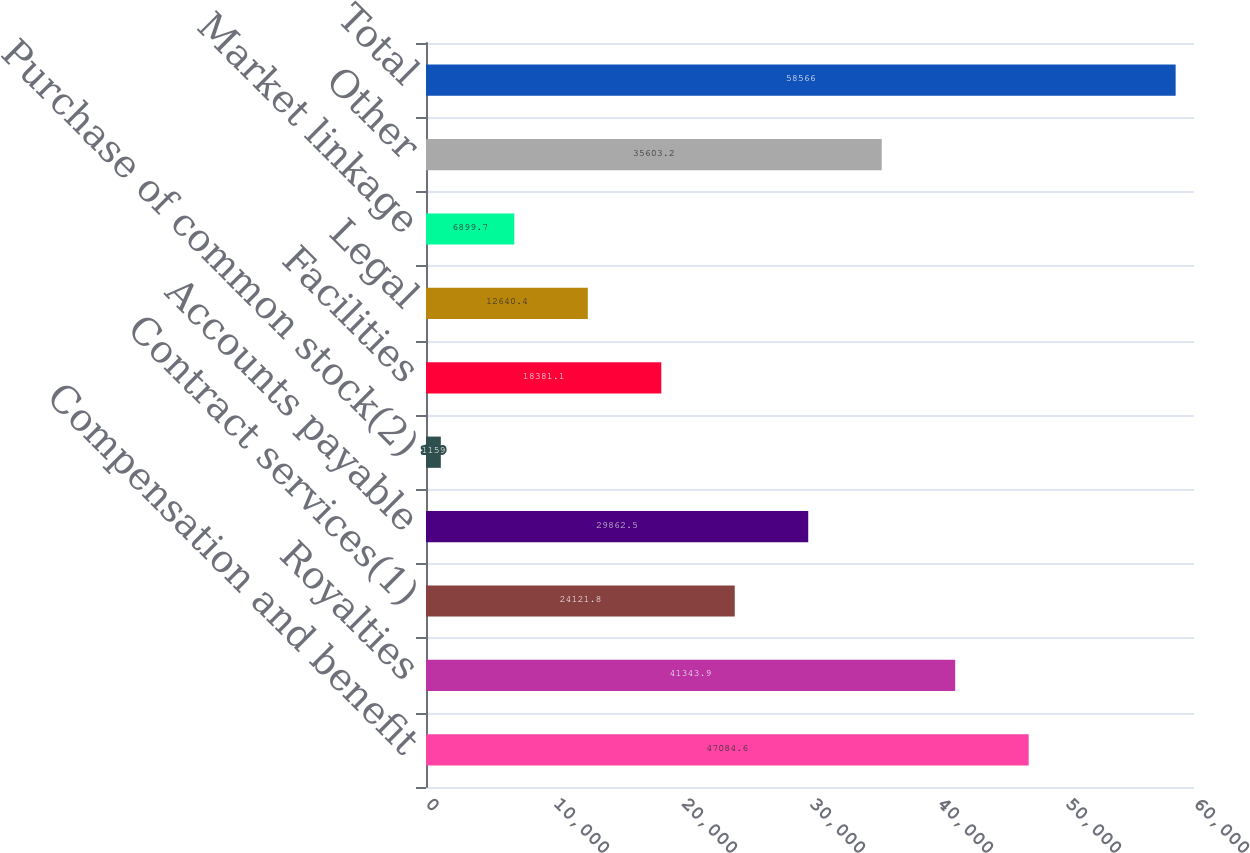Convert chart. <chart><loc_0><loc_0><loc_500><loc_500><bar_chart><fcel>Compensation and benefit<fcel>Royalties<fcel>Contract services(1)<fcel>Accounts payable<fcel>Purchase of common stock(2)<fcel>Facilities<fcel>Legal<fcel>Market linkage<fcel>Other<fcel>Total<nl><fcel>47084.6<fcel>41343.9<fcel>24121.8<fcel>29862.5<fcel>1159<fcel>18381.1<fcel>12640.4<fcel>6899.7<fcel>35603.2<fcel>58566<nl></chart> 